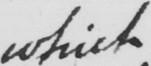Transcribe the text shown in this historical manuscript line. which 